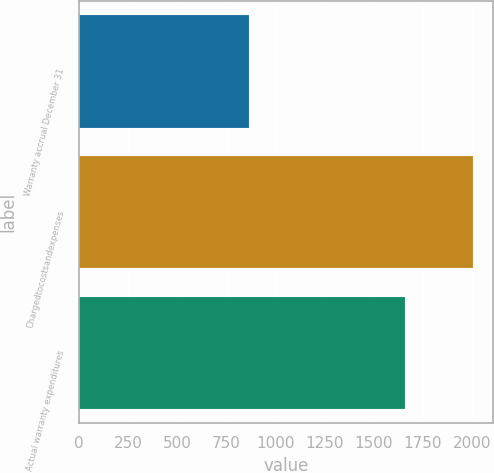<chart> <loc_0><loc_0><loc_500><loc_500><bar_chart><fcel>Warranty accrual December 31<fcel>Chargedtocostsandexpenses<fcel>Actual warranty expenditures<nl><fcel>862<fcel>2004<fcel>1656<nl></chart> 